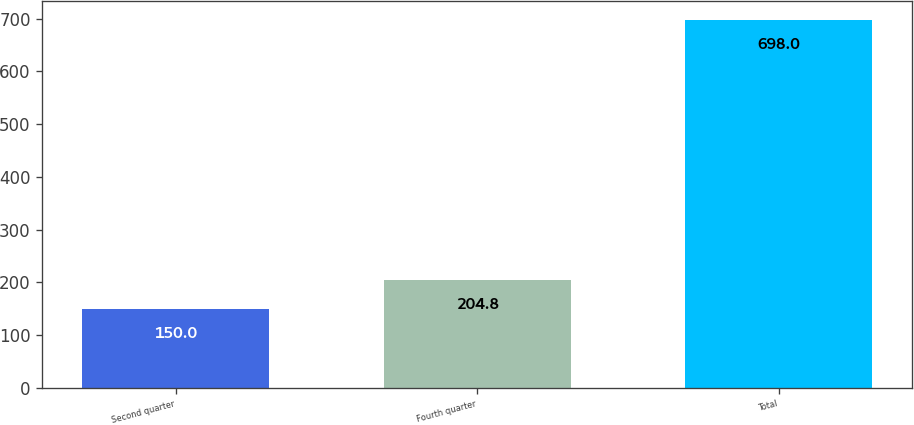Convert chart. <chart><loc_0><loc_0><loc_500><loc_500><bar_chart><fcel>Second quarter<fcel>Fourth quarter<fcel>Total<nl><fcel>150<fcel>204.8<fcel>698<nl></chart> 